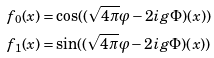<formula> <loc_0><loc_0><loc_500><loc_500>f _ { 0 } ( x ) = & \cos ( ( \sqrt { 4 \pi } \varphi - 2 i g \Phi ) ( x ) ) \\ f _ { 1 } ( x ) = & \sin ( ( \sqrt { 4 \pi } \varphi - 2 i g \Phi ) ( x ) )</formula> 